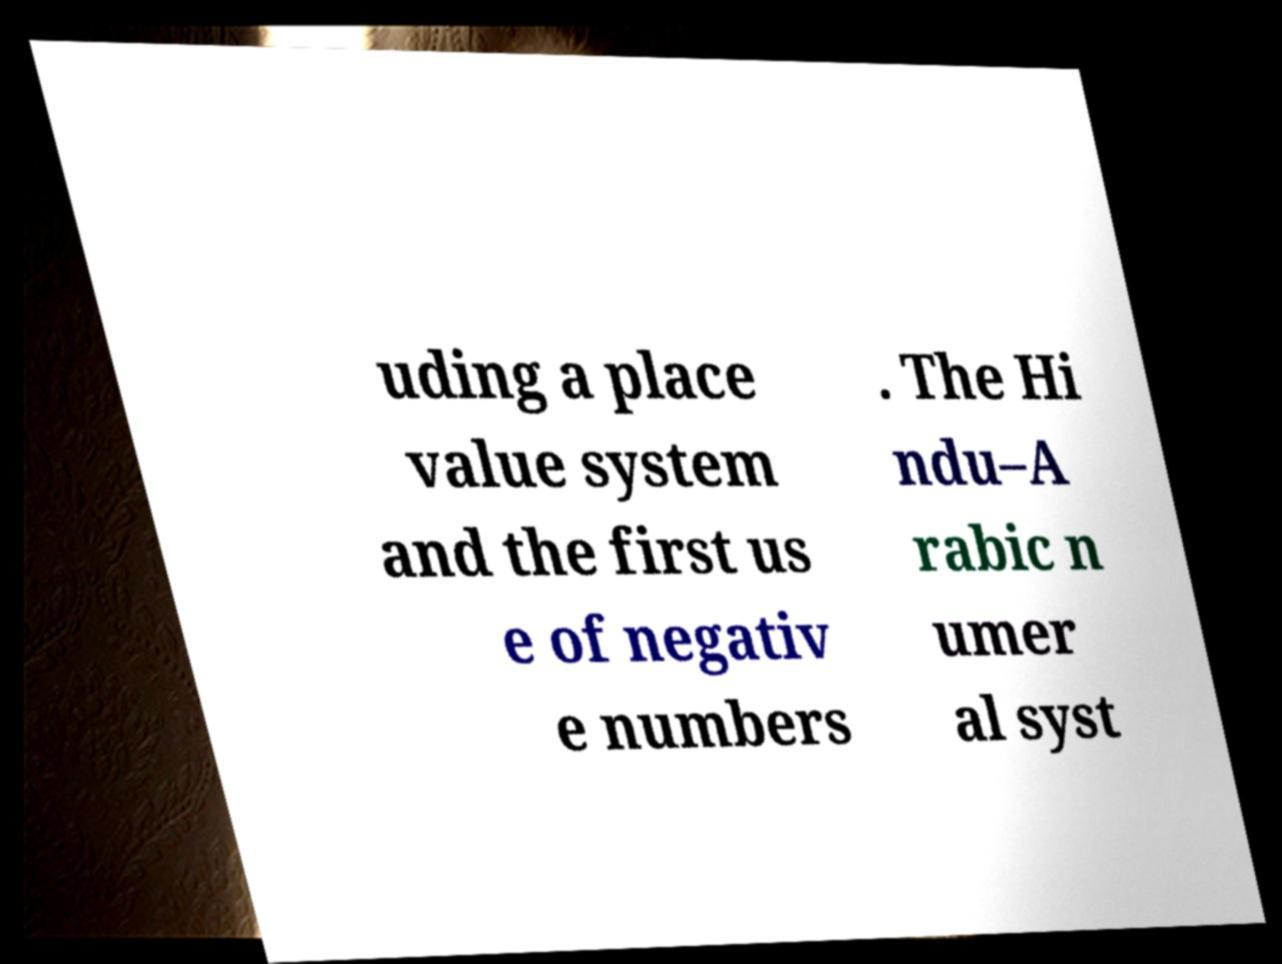There's text embedded in this image that I need extracted. Can you transcribe it verbatim? uding a place value system and the first us e of negativ e numbers . The Hi ndu–A rabic n umer al syst 